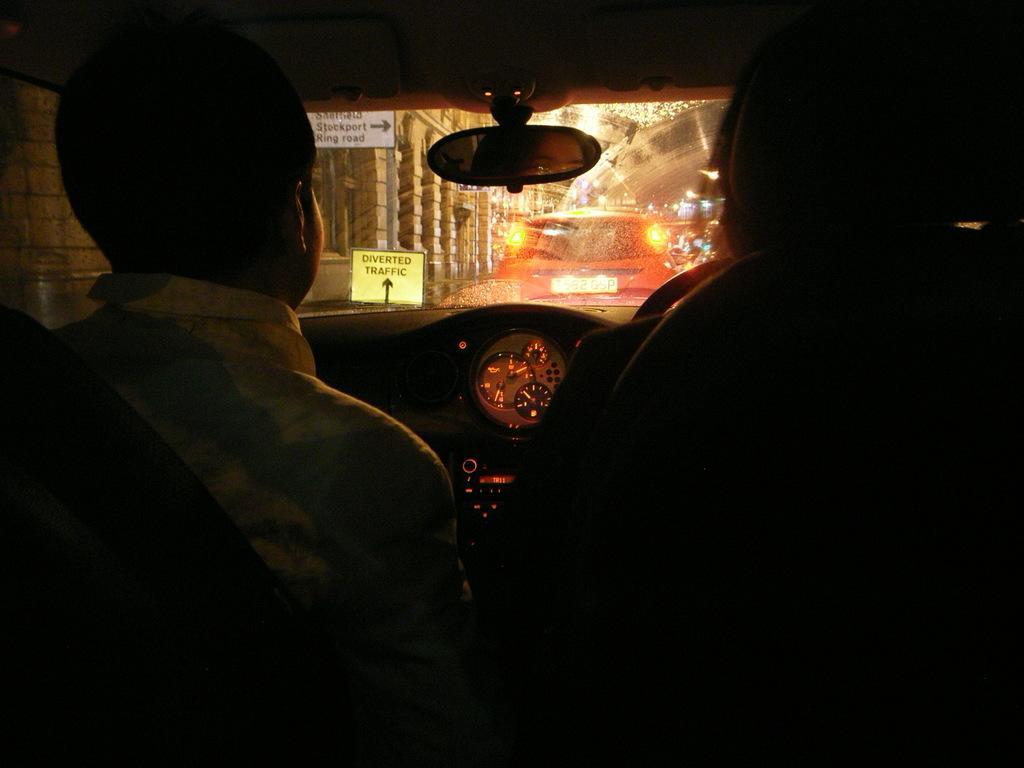In one or two sentences, can you explain what this image depicts? In this image there are two people sitting in a car, in front of them there is steering, dashboard, rear view mirror and windshield, from the windshield we can see a few cars on the road, sign boards and buildings. 